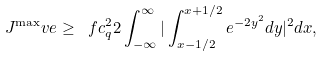Convert formula to latex. <formula><loc_0><loc_0><loc_500><loc_500>J ^ { \max } _ { \ } v e \geq \ f { c _ { q } ^ { 2 } } { 2 } \int _ { - \infty } ^ { \infty } | \int _ { x - 1 / 2 } ^ { x + 1 / 2 } e ^ { - 2 y ^ { 2 } } d y | ^ { 2 } d x ,</formula> 